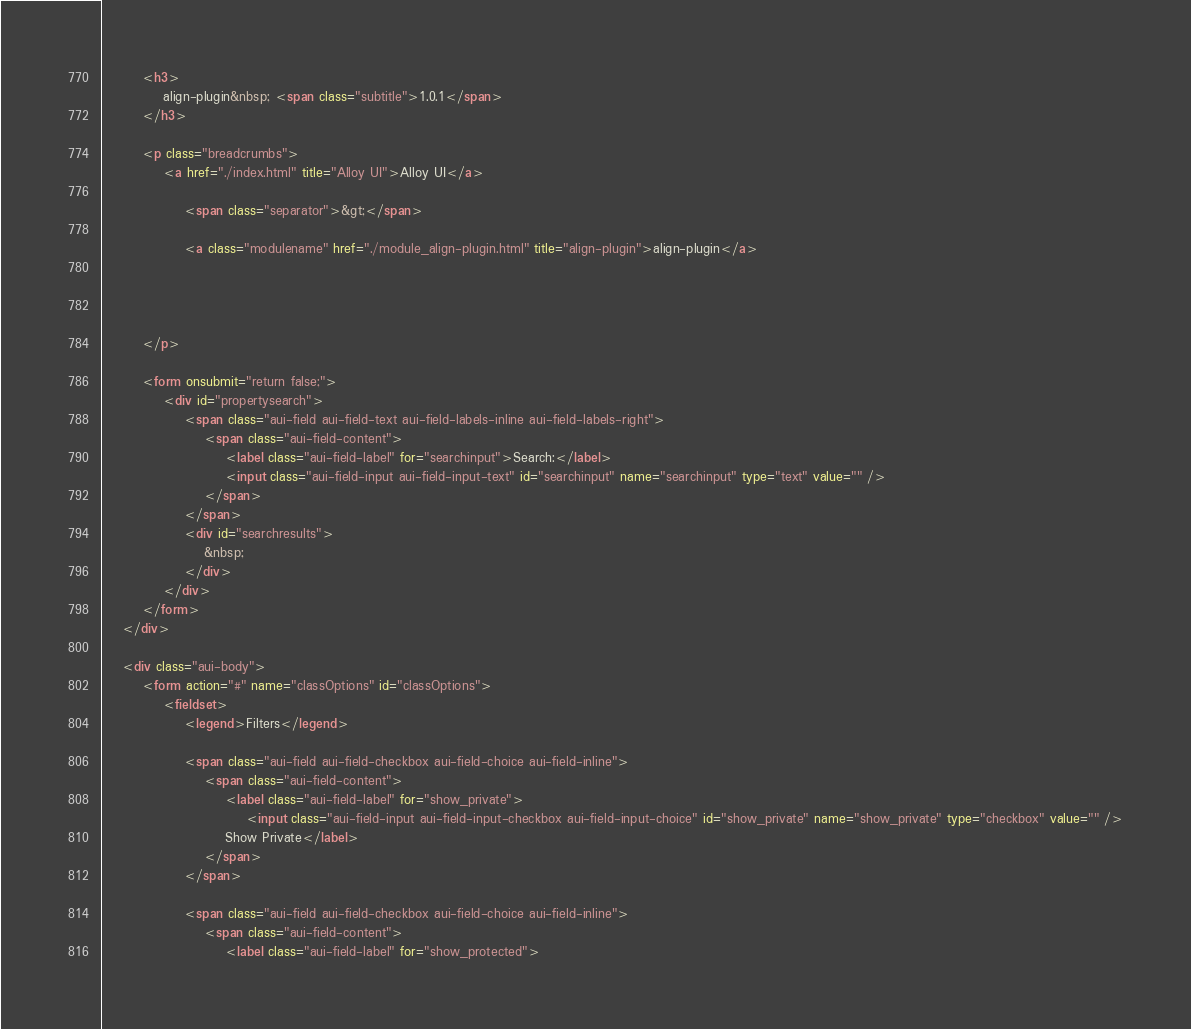<code> <loc_0><loc_0><loc_500><loc_500><_HTML_>
		<h3>
			align-plugin&nbsp; <span class="subtitle">1.0.1</span>
		</h3>

		<p class="breadcrumbs">
			<a href="./index.html" title="Alloy UI">Alloy UI</a>

	            <span class="separator">&gt;</span>

				<a class="modulename" href="./module_align-plugin.html" title="align-plugin">align-plugin</a>

	                

	                
		</p>

		<form onsubmit="return false;">
            <div id="propertysearch">
				<span class="aui-field aui-field-text aui-field-labels-inline aui-field-labels-right">
					<span class="aui-field-content">
						<label class="aui-field-label" for="searchinput">Search:</label>
						<input class="aui-field-input aui-field-input-text" id="searchinput" name="searchinput" type="text" value="" />
					</span>
				</span>
                <div id="searchresults">
                    &nbsp;
                </div>
            </div>
        </form>
	</div>

	<div class="aui-body">
		<form action="#" name="classOptions" id="classOptions">
			<fieldset>
				<legend>Filters</legend>

				<span class="aui-field aui-field-checkbox aui-field-choice aui-field-inline">
					<span class="aui-field-content">
						<label class="aui-field-label" for="show_private">
							<input class="aui-field-input aui-field-input-checkbox aui-field-input-choice" id="show_private" name="show_private" type="checkbox" value="" />
						Show Private</label>
					</span>
				</span>

				<span class="aui-field aui-field-checkbox aui-field-choice aui-field-inline">
					<span class="aui-field-content">
						<label class="aui-field-label" for="show_protected"></code> 